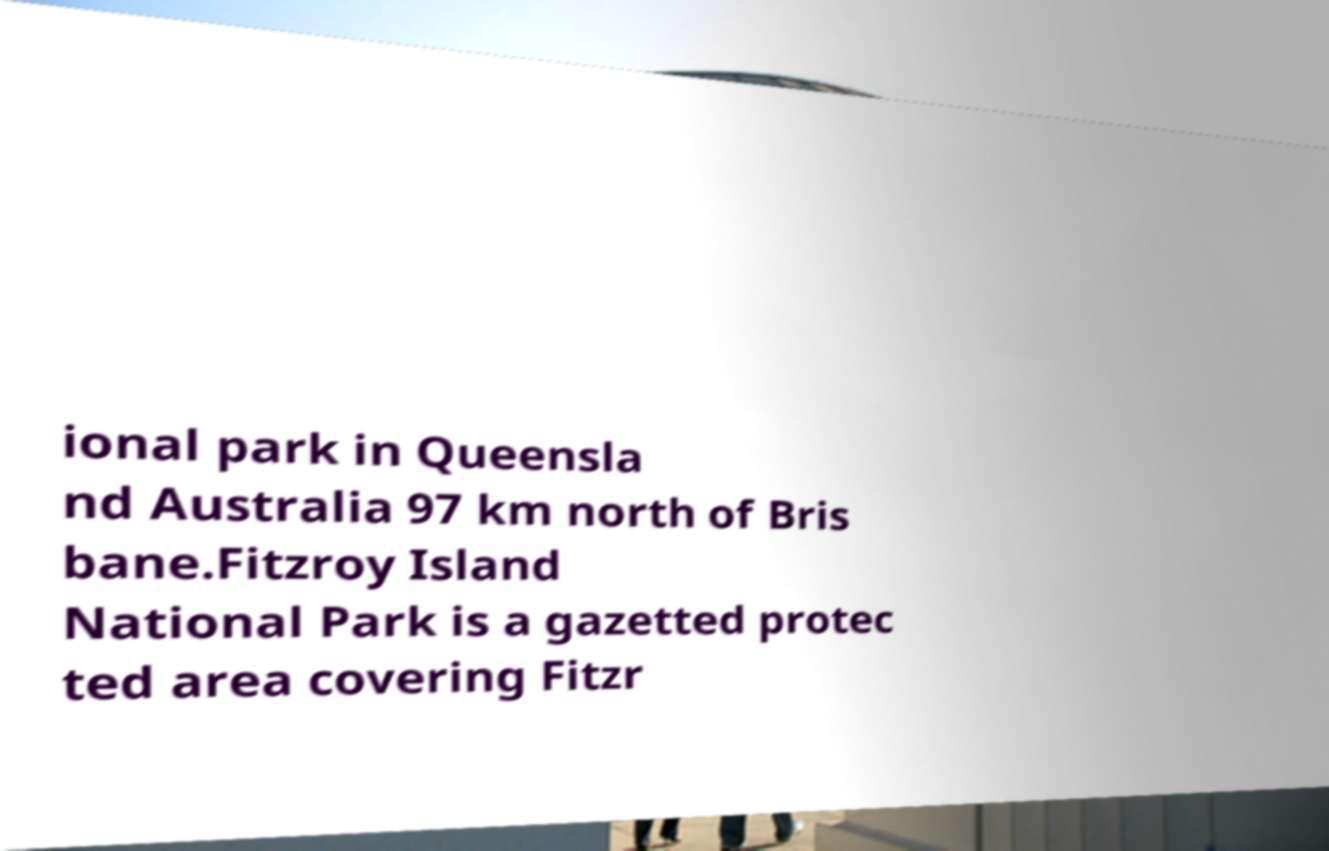I need the written content from this picture converted into text. Can you do that? ional park in Queensla nd Australia 97 km north of Bris bane.Fitzroy Island National Park is a gazetted protec ted area covering Fitzr 